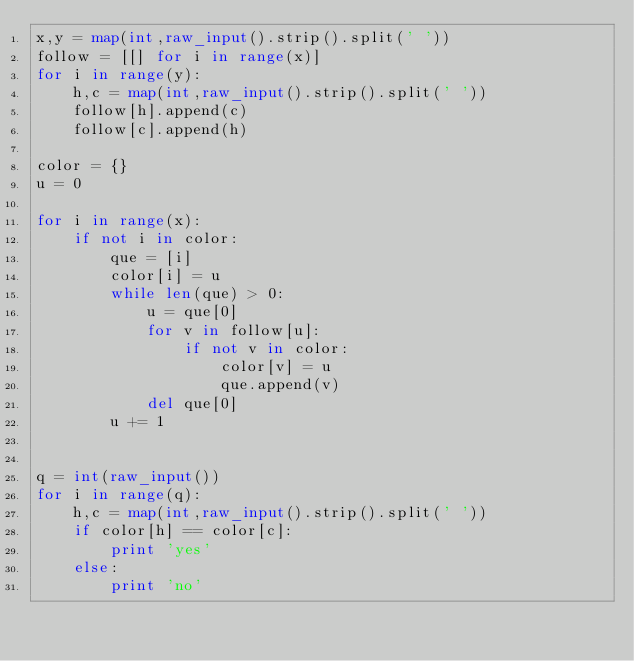Convert code to text. <code><loc_0><loc_0><loc_500><loc_500><_Python_>x,y = map(int,raw_input().strip().split(' '))
follow = [[] for i in range(x)]
for i in range(y):
    h,c = map(int,raw_input().strip().split(' '))
    follow[h].append(c)
    follow[c].append(h)
 
color = {}
u = 0

for i in range(x):
    if not i in color:
        que = [i]
        color[i] = u
        while len(que) > 0:
            u = que[0]
            for v in follow[u]:
                if not v in color:
                    color[v] = u
                    que.append(v)
            del que[0]
        u += 1
 
 
q = int(raw_input())
for i in range(q):
    h,c = map(int,raw_input().strip().split(' '))
    if color[h] == color[c]:
        print 'yes'
    else:
        print 'no'</code> 